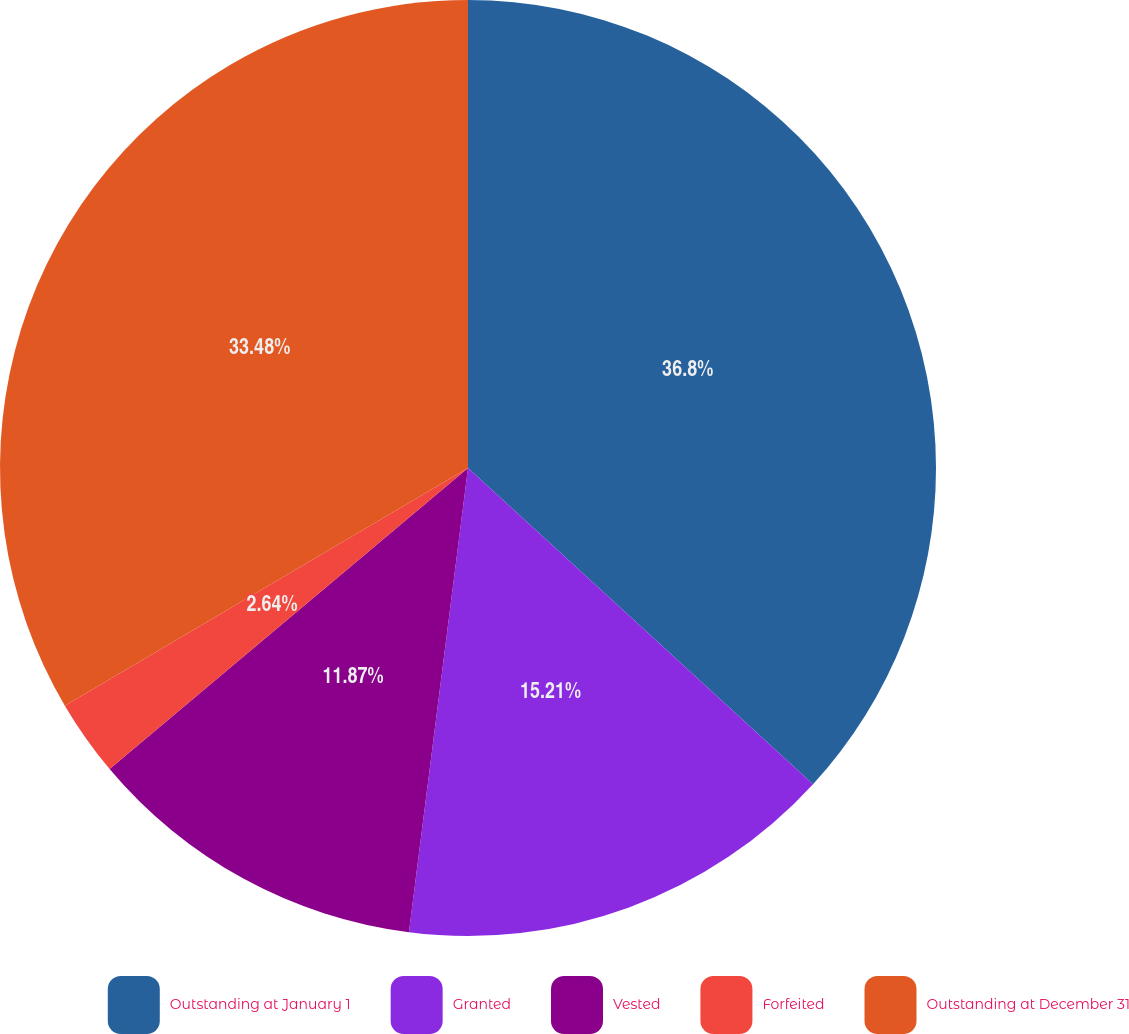Convert chart. <chart><loc_0><loc_0><loc_500><loc_500><pie_chart><fcel>Outstanding at January 1<fcel>Granted<fcel>Vested<fcel>Forfeited<fcel>Outstanding at December 31<nl><fcel>36.81%<fcel>15.21%<fcel>11.87%<fcel>2.64%<fcel>33.48%<nl></chart> 